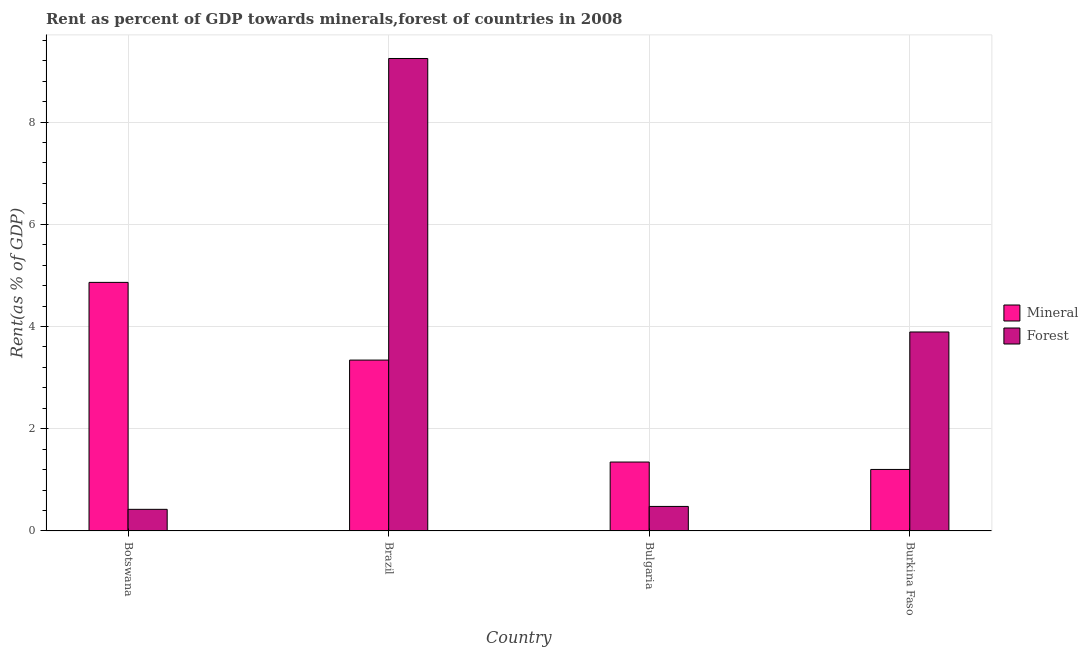How many groups of bars are there?
Ensure brevity in your answer.  4. How many bars are there on the 1st tick from the left?
Offer a terse response. 2. What is the label of the 2nd group of bars from the left?
Offer a very short reply. Brazil. In how many cases, is the number of bars for a given country not equal to the number of legend labels?
Ensure brevity in your answer.  0. What is the forest rent in Bulgaria?
Ensure brevity in your answer.  0.48. Across all countries, what is the maximum mineral rent?
Make the answer very short. 4.86. Across all countries, what is the minimum forest rent?
Offer a very short reply. 0.42. In which country was the mineral rent minimum?
Keep it short and to the point. Burkina Faso. What is the total mineral rent in the graph?
Provide a succinct answer. 10.76. What is the difference between the mineral rent in Botswana and that in Burkina Faso?
Your answer should be compact. 3.66. What is the difference between the mineral rent in Bulgaria and the forest rent in Botswana?
Give a very brief answer. 0.93. What is the average forest rent per country?
Your answer should be very brief. 3.51. What is the difference between the forest rent and mineral rent in Botswana?
Offer a very short reply. -4.44. In how many countries, is the forest rent greater than 7.6 %?
Your answer should be compact. 1. What is the ratio of the forest rent in Brazil to that in Burkina Faso?
Offer a very short reply. 2.37. What is the difference between the highest and the second highest forest rent?
Provide a short and direct response. 5.35. What is the difference between the highest and the lowest forest rent?
Keep it short and to the point. 8.82. What does the 2nd bar from the left in Brazil represents?
Provide a short and direct response. Forest. What does the 1st bar from the right in Brazil represents?
Your answer should be compact. Forest. How many countries are there in the graph?
Offer a very short reply. 4. What is the difference between two consecutive major ticks on the Y-axis?
Your response must be concise. 2. Are the values on the major ticks of Y-axis written in scientific E-notation?
Make the answer very short. No. Does the graph contain any zero values?
Keep it short and to the point. No. Does the graph contain grids?
Your answer should be very brief. Yes. How many legend labels are there?
Offer a terse response. 2. How are the legend labels stacked?
Make the answer very short. Vertical. What is the title of the graph?
Give a very brief answer. Rent as percent of GDP towards minerals,forest of countries in 2008. Does "Female labor force" appear as one of the legend labels in the graph?
Provide a short and direct response. No. What is the label or title of the Y-axis?
Give a very brief answer. Rent(as % of GDP). What is the Rent(as % of GDP) of Mineral in Botswana?
Your answer should be compact. 4.86. What is the Rent(as % of GDP) in Forest in Botswana?
Your answer should be compact. 0.42. What is the Rent(as % of GDP) in Mineral in Brazil?
Your answer should be compact. 3.34. What is the Rent(as % of GDP) in Forest in Brazil?
Provide a short and direct response. 9.24. What is the Rent(as % of GDP) in Mineral in Bulgaria?
Your answer should be compact. 1.35. What is the Rent(as % of GDP) in Forest in Bulgaria?
Provide a short and direct response. 0.48. What is the Rent(as % of GDP) in Mineral in Burkina Faso?
Give a very brief answer. 1.2. What is the Rent(as % of GDP) of Forest in Burkina Faso?
Ensure brevity in your answer.  3.89. Across all countries, what is the maximum Rent(as % of GDP) of Mineral?
Keep it short and to the point. 4.86. Across all countries, what is the maximum Rent(as % of GDP) of Forest?
Your answer should be compact. 9.24. Across all countries, what is the minimum Rent(as % of GDP) in Mineral?
Your answer should be very brief. 1.2. Across all countries, what is the minimum Rent(as % of GDP) of Forest?
Make the answer very short. 0.42. What is the total Rent(as % of GDP) in Mineral in the graph?
Your answer should be compact. 10.76. What is the total Rent(as % of GDP) of Forest in the graph?
Your response must be concise. 14.04. What is the difference between the Rent(as % of GDP) in Mineral in Botswana and that in Brazil?
Your answer should be compact. 1.52. What is the difference between the Rent(as % of GDP) of Forest in Botswana and that in Brazil?
Ensure brevity in your answer.  -8.82. What is the difference between the Rent(as % of GDP) of Mineral in Botswana and that in Bulgaria?
Offer a very short reply. 3.51. What is the difference between the Rent(as % of GDP) in Forest in Botswana and that in Bulgaria?
Your answer should be very brief. -0.06. What is the difference between the Rent(as % of GDP) of Mineral in Botswana and that in Burkina Faso?
Offer a very short reply. 3.66. What is the difference between the Rent(as % of GDP) of Forest in Botswana and that in Burkina Faso?
Offer a very short reply. -3.47. What is the difference between the Rent(as % of GDP) of Mineral in Brazil and that in Bulgaria?
Make the answer very short. 1.99. What is the difference between the Rent(as % of GDP) in Forest in Brazil and that in Bulgaria?
Your answer should be compact. 8.76. What is the difference between the Rent(as % of GDP) in Mineral in Brazil and that in Burkina Faso?
Your response must be concise. 2.14. What is the difference between the Rent(as % of GDP) in Forest in Brazil and that in Burkina Faso?
Keep it short and to the point. 5.35. What is the difference between the Rent(as % of GDP) of Mineral in Bulgaria and that in Burkina Faso?
Provide a succinct answer. 0.14. What is the difference between the Rent(as % of GDP) of Forest in Bulgaria and that in Burkina Faso?
Give a very brief answer. -3.41. What is the difference between the Rent(as % of GDP) of Mineral in Botswana and the Rent(as % of GDP) of Forest in Brazil?
Your answer should be very brief. -4.38. What is the difference between the Rent(as % of GDP) in Mineral in Botswana and the Rent(as % of GDP) in Forest in Bulgaria?
Keep it short and to the point. 4.38. What is the difference between the Rent(as % of GDP) in Mineral in Botswana and the Rent(as % of GDP) in Forest in Burkina Faso?
Make the answer very short. 0.97. What is the difference between the Rent(as % of GDP) of Mineral in Brazil and the Rent(as % of GDP) of Forest in Bulgaria?
Offer a terse response. 2.86. What is the difference between the Rent(as % of GDP) in Mineral in Brazil and the Rent(as % of GDP) in Forest in Burkina Faso?
Ensure brevity in your answer.  -0.55. What is the difference between the Rent(as % of GDP) in Mineral in Bulgaria and the Rent(as % of GDP) in Forest in Burkina Faso?
Offer a terse response. -2.54. What is the average Rent(as % of GDP) of Mineral per country?
Provide a succinct answer. 2.69. What is the average Rent(as % of GDP) of Forest per country?
Offer a terse response. 3.51. What is the difference between the Rent(as % of GDP) in Mineral and Rent(as % of GDP) in Forest in Botswana?
Provide a succinct answer. 4.44. What is the difference between the Rent(as % of GDP) in Mineral and Rent(as % of GDP) in Forest in Brazil?
Give a very brief answer. -5.9. What is the difference between the Rent(as % of GDP) in Mineral and Rent(as % of GDP) in Forest in Bulgaria?
Your answer should be compact. 0.87. What is the difference between the Rent(as % of GDP) of Mineral and Rent(as % of GDP) of Forest in Burkina Faso?
Your response must be concise. -2.69. What is the ratio of the Rent(as % of GDP) in Mineral in Botswana to that in Brazil?
Give a very brief answer. 1.45. What is the ratio of the Rent(as % of GDP) of Forest in Botswana to that in Brazil?
Your response must be concise. 0.05. What is the ratio of the Rent(as % of GDP) of Mineral in Botswana to that in Bulgaria?
Give a very brief answer. 3.61. What is the ratio of the Rent(as % of GDP) in Forest in Botswana to that in Bulgaria?
Give a very brief answer. 0.88. What is the ratio of the Rent(as % of GDP) of Mineral in Botswana to that in Burkina Faso?
Your answer should be compact. 4.04. What is the ratio of the Rent(as % of GDP) in Forest in Botswana to that in Burkina Faso?
Keep it short and to the point. 0.11. What is the ratio of the Rent(as % of GDP) in Mineral in Brazil to that in Bulgaria?
Offer a terse response. 2.48. What is the ratio of the Rent(as % of GDP) in Forest in Brazil to that in Bulgaria?
Your answer should be compact. 19.27. What is the ratio of the Rent(as % of GDP) of Mineral in Brazil to that in Burkina Faso?
Give a very brief answer. 2.78. What is the ratio of the Rent(as % of GDP) of Forest in Brazil to that in Burkina Faso?
Your answer should be compact. 2.37. What is the ratio of the Rent(as % of GDP) of Mineral in Bulgaria to that in Burkina Faso?
Give a very brief answer. 1.12. What is the ratio of the Rent(as % of GDP) in Forest in Bulgaria to that in Burkina Faso?
Your answer should be very brief. 0.12. What is the difference between the highest and the second highest Rent(as % of GDP) of Mineral?
Give a very brief answer. 1.52. What is the difference between the highest and the second highest Rent(as % of GDP) of Forest?
Give a very brief answer. 5.35. What is the difference between the highest and the lowest Rent(as % of GDP) of Mineral?
Provide a succinct answer. 3.66. What is the difference between the highest and the lowest Rent(as % of GDP) of Forest?
Provide a succinct answer. 8.82. 